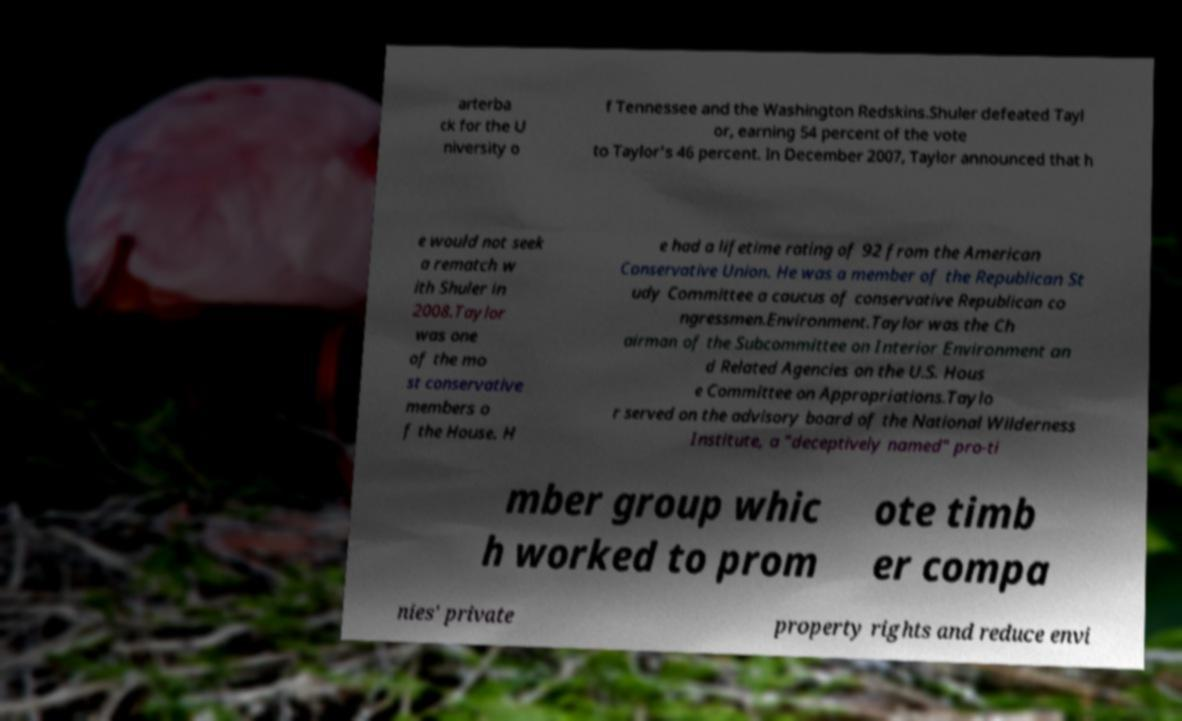Can you accurately transcribe the text from the provided image for me? arterba ck for the U niversity o f Tennessee and the Washington Redskins.Shuler defeated Tayl or, earning 54 percent of the vote to Taylor's 46 percent. In December 2007, Taylor announced that h e would not seek a rematch w ith Shuler in 2008.Taylor was one of the mo st conservative members o f the House. H e had a lifetime rating of 92 from the American Conservative Union. He was a member of the Republican St udy Committee a caucus of conservative Republican co ngressmen.Environment.Taylor was the Ch airman of the Subcommittee on Interior Environment an d Related Agencies on the U.S. Hous e Committee on Appropriations.Taylo r served on the advisory board of the National Wilderness Institute, a "deceptively named" pro-ti mber group whic h worked to prom ote timb er compa nies' private property rights and reduce envi 